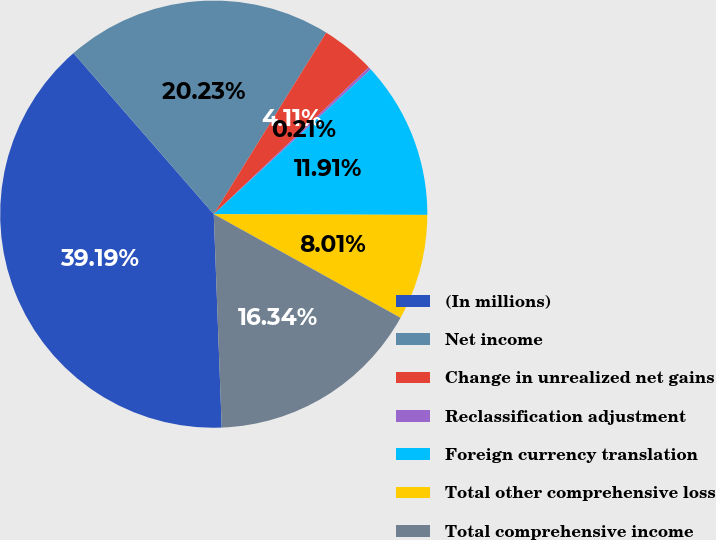Convert chart to OTSL. <chart><loc_0><loc_0><loc_500><loc_500><pie_chart><fcel>(In millions)<fcel>Net income<fcel>Change in unrealized net gains<fcel>Reclassification adjustment<fcel>Foreign currency translation<fcel>Total other comprehensive loss<fcel>Total comprehensive income<nl><fcel>39.19%<fcel>20.23%<fcel>4.11%<fcel>0.21%<fcel>11.91%<fcel>8.01%<fcel>16.34%<nl></chart> 